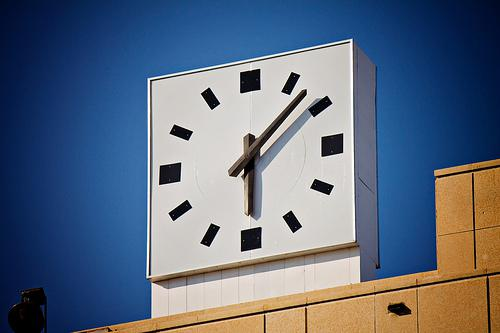Question: when was this photo taken?
Choices:
A. 12:15.
B. 1:45.
C. 7:30.
D. 6:07.
Answer with the letter. Answer: D Question: what material is the platform the clock in on made of?
Choices:
A. Wood.
B. Plastic.
C. Metal.
D. Rubber.
Answer with the letter. Answer: A Question: what shape is the clock?
Choices:
A. Circle.
B. Trapezoid.
C. Square.
D. Rectangle.
Answer with the letter. Answer: C 